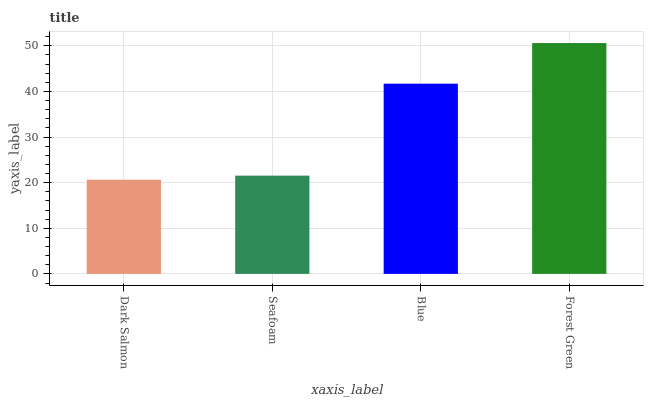Is Dark Salmon the minimum?
Answer yes or no. Yes. Is Forest Green the maximum?
Answer yes or no. Yes. Is Seafoam the minimum?
Answer yes or no. No. Is Seafoam the maximum?
Answer yes or no. No. Is Seafoam greater than Dark Salmon?
Answer yes or no. Yes. Is Dark Salmon less than Seafoam?
Answer yes or no. Yes. Is Dark Salmon greater than Seafoam?
Answer yes or no. No. Is Seafoam less than Dark Salmon?
Answer yes or no. No. Is Blue the high median?
Answer yes or no. Yes. Is Seafoam the low median?
Answer yes or no. Yes. Is Dark Salmon the high median?
Answer yes or no. No. Is Forest Green the low median?
Answer yes or no. No. 